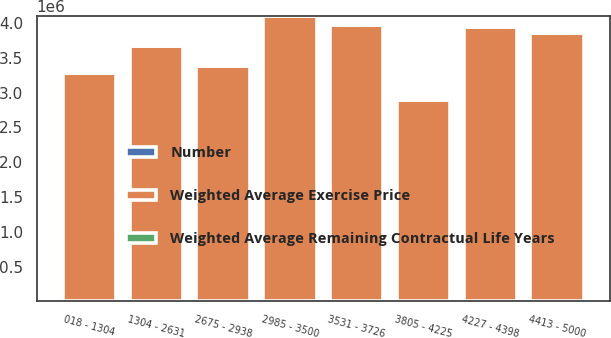Convert chart to OTSL. <chart><loc_0><loc_0><loc_500><loc_500><stacked_bar_chart><ecel><fcel>018 - 1304<fcel>1304 - 2631<fcel>2675 - 2938<fcel>2985 - 3500<fcel>3531 - 3726<fcel>3805 - 4225<fcel>4227 - 4398<fcel>4413 - 5000<nl><fcel>Weighted Average Exercise Price<fcel>3.28356e+06<fcel>3.66467e+06<fcel>3.38643e+06<fcel>4.10391e+06<fcel>3.96564e+06<fcel>2.88658e+06<fcel>3.94251e+06<fcel>3.85123e+06<nl><fcel>Number<fcel>3.81<fcel>5.43<fcel>6.59<fcel>7.19<fcel>7.89<fcel>7.54<fcel>6.83<fcel>6.63<nl><fcel>Weighted Average Remaining Contractual Life Years<fcel>8.8<fcel>19.93<fcel>28.77<fcel>32.91<fcel>36.98<fcel>40.11<fcel>42.79<fcel>46.21<nl></chart> 